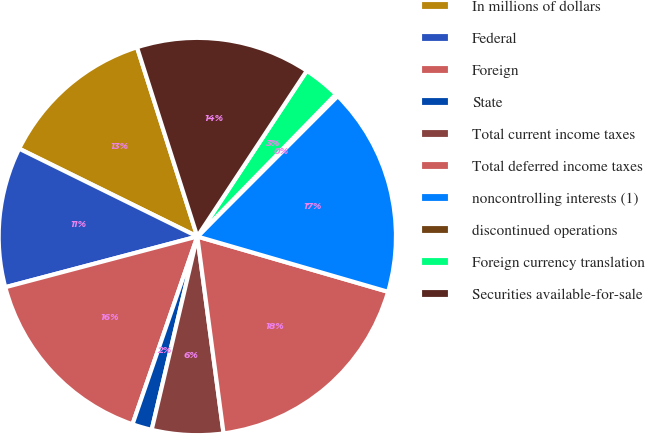Convert chart. <chart><loc_0><loc_0><loc_500><loc_500><pie_chart><fcel>In millions of dollars<fcel>Federal<fcel>Foreign<fcel>State<fcel>Total current income taxes<fcel>Total deferred income taxes<fcel>noncontrolling interests (1)<fcel>discontinued operations<fcel>Foreign currency translation<fcel>Securities available-for-sale<nl><fcel>12.8%<fcel>11.4%<fcel>15.6%<fcel>1.6%<fcel>5.8%<fcel>18.4%<fcel>17.0%<fcel>0.2%<fcel>3.0%<fcel>14.2%<nl></chart> 